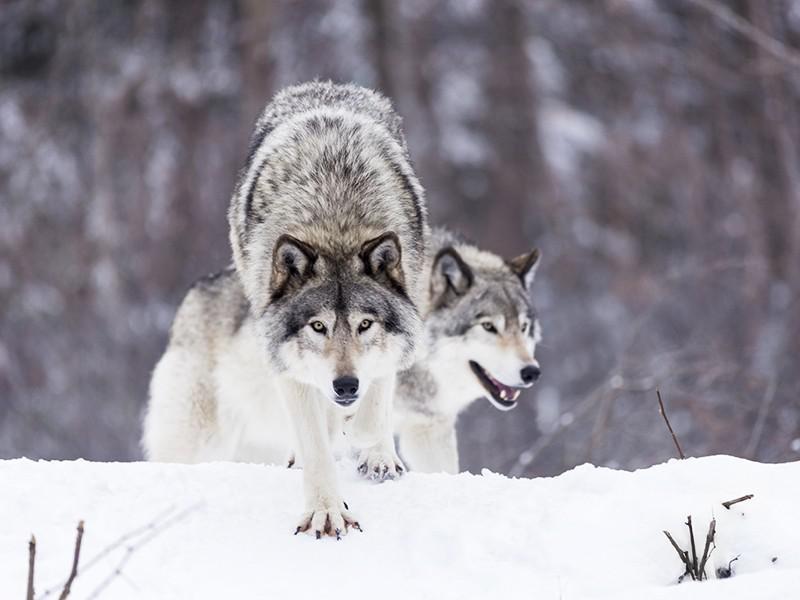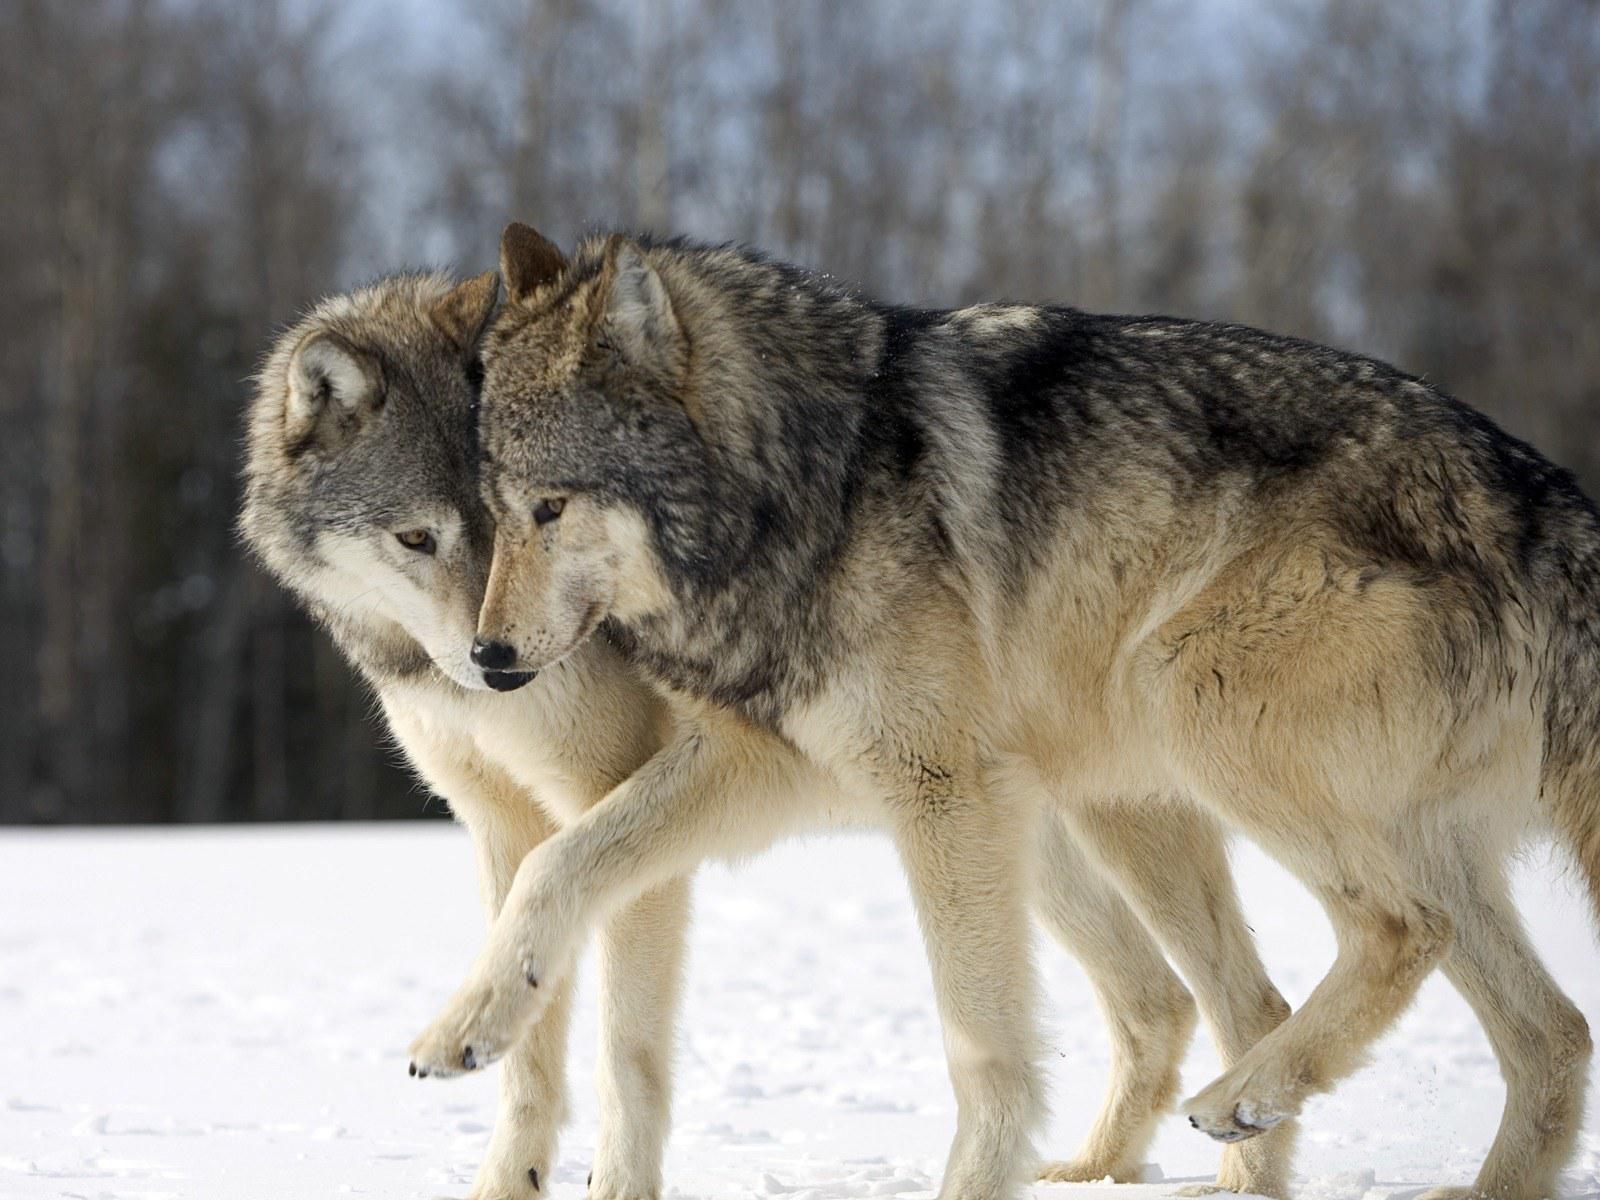The first image is the image on the left, the second image is the image on the right. Analyze the images presented: Is the assertion "The left image includes a dog moving forward over snow toward the camera, and it includes a dog with an open mouth." valid? Answer yes or no. Yes. 